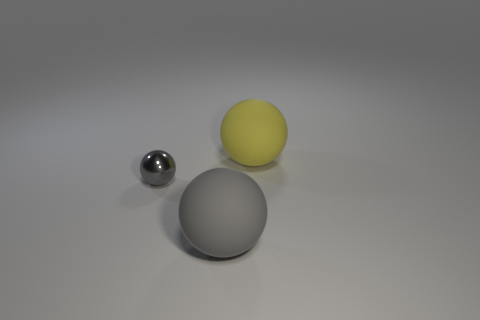There is another gray thing that is the same shape as the large gray thing; what is its material?
Make the answer very short. Metal. Is there anything else that is the same size as the metallic thing?
Your answer should be very brief. No. The tiny gray thing that is in front of the big matte sphere behind the matte ball in front of the yellow rubber sphere is made of what material?
Make the answer very short. Metal. How many things are either big blue rubber spheres or gray things?
Provide a short and direct response. 2. Are there any other large objects made of the same material as the large yellow thing?
Ensure brevity in your answer.  Yes. There is a big thing in front of the tiny gray thing; are there any gray matte objects that are in front of it?
Provide a short and direct response. No. There is a matte ball that is behind the gray metal sphere; is its size the same as the small metal thing?
Your answer should be compact. No. What size is the yellow matte sphere?
Your response must be concise. Large. Is there a metallic sphere that has the same color as the shiny object?
Your answer should be compact. No. What number of large things are either gray spheres or rubber balls?
Provide a succinct answer. 2. 